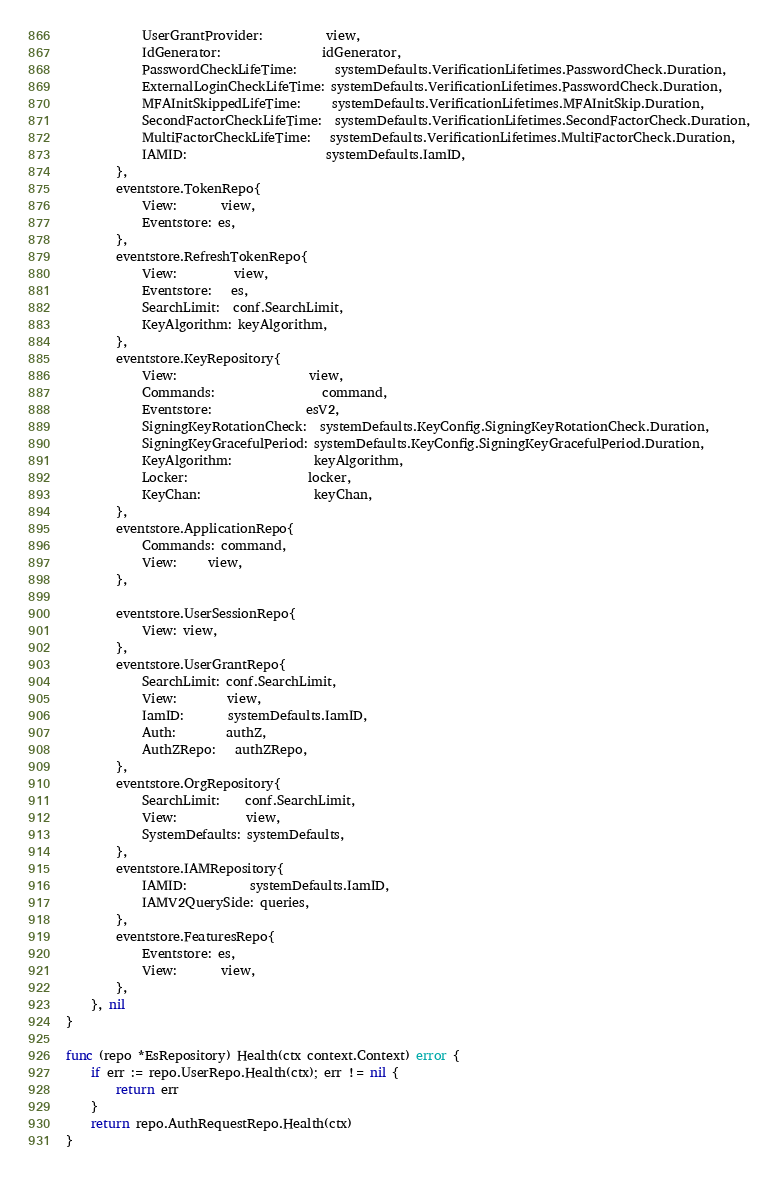<code> <loc_0><loc_0><loc_500><loc_500><_Go_>			UserGrantProvider:          view,
			IdGenerator:                idGenerator,
			PasswordCheckLifeTime:      systemDefaults.VerificationLifetimes.PasswordCheck.Duration,
			ExternalLoginCheckLifeTime: systemDefaults.VerificationLifetimes.PasswordCheck.Duration,
			MFAInitSkippedLifeTime:     systemDefaults.VerificationLifetimes.MFAInitSkip.Duration,
			SecondFactorCheckLifeTime:  systemDefaults.VerificationLifetimes.SecondFactorCheck.Duration,
			MultiFactorCheckLifeTime:   systemDefaults.VerificationLifetimes.MultiFactorCheck.Duration,
			IAMID:                      systemDefaults.IamID,
		},
		eventstore.TokenRepo{
			View:       view,
			Eventstore: es,
		},
		eventstore.RefreshTokenRepo{
			View:         view,
			Eventstore:   es,
			SearchLimit:  conf.SearchLimit,
			KeyAlgorithm: keyAlgorithm,
		},
		eventstore.KeyRepository{
			View:                     view,
			Commands:                 command,
			Eventstore:               esV2,
			SigningKeyRotationCheck:  systemDefaults.KeyConfig.SigningKeyRotationCheck.Duration,
			SigningKeyGracefulPeriod: systemDefaults.KeyConfig.SigningKeyGracefulPeriod.Duration,
			KeyAlgorithm:             keyAlgorithm,
			Locker:                   locker,
			KeyChan:                  keyChan,
		},
		eventstore.ApplicationRepo{
			Commands: command,
			View:     view,
		},

		eventstore.UserSessionRepo{
			View: view,
		},
		eventstore.UserGrantRepo{
			SearchLimit: conf.SearchLimit,
			View:        view,
			IamID:       systemDefaults.IamID,
			Auth:        authZ,
			AuthZRepo:   authZRepo,
		},
		eventstore.OrgRepository{
			SearchLimit:    conf.SearchLimit,
			View:           view,
			SystemDefaults: systemDefaults,
		},
		eventstore.IAMRepository{
			IAMID:          systemDefaults.IamID,
			IAMV2QuerySide: queries,
		},
		eventstore.FeaturesRepo{
			Eventstore: es,
			View:       view,
		},
	}, nil
}

func (repo *EsRepository) Health(ctx context.Context) error {
	if err := repo.UserRepo.Health(ctx); err != nil {
		return err
	}
	return repo.AuthRequestRepo.Health(ctx)
}
</code> 